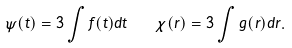Convert formula to latex. <formula><loc_0><loc_0><loc_500><loc_500>\psi ( t ) = 3 \int f ( t ) d t \quad \chi ( r ) = 3 \int g ( r ) d r .</formula> 